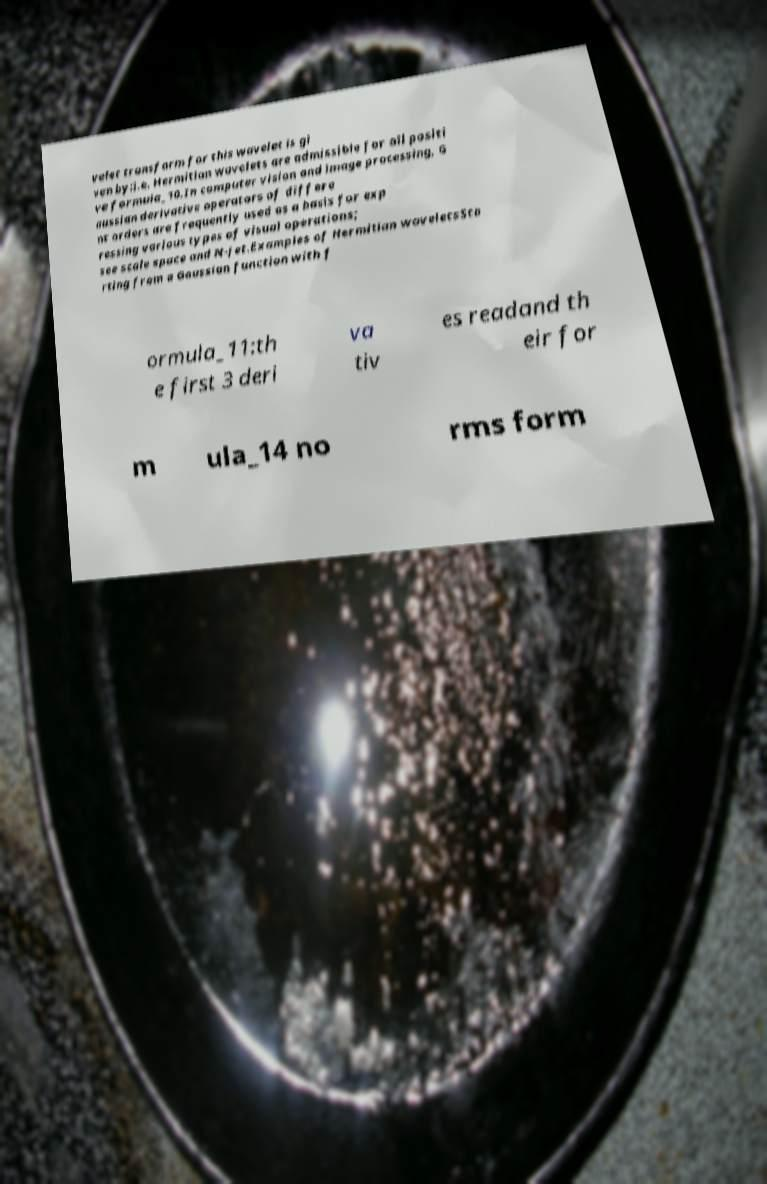Could you assist in decoding the text presented in this image and type it out clearly? velet transform for this wavelet is gi ven by:i.e. Hermitian wavelets are admissible for all positi ve formula_10.In computer vision and image processing, G aussian derivative operators of differe nt orders are frequently used as a basis for exp ressing various types of visual operations; see scale space and N-jet.Examples of Hermitian waveletsSta rting from a Gaussian function with f ormula_11:th e first 3 deri va tiv es readand th eir for m ula_14 no rms form 